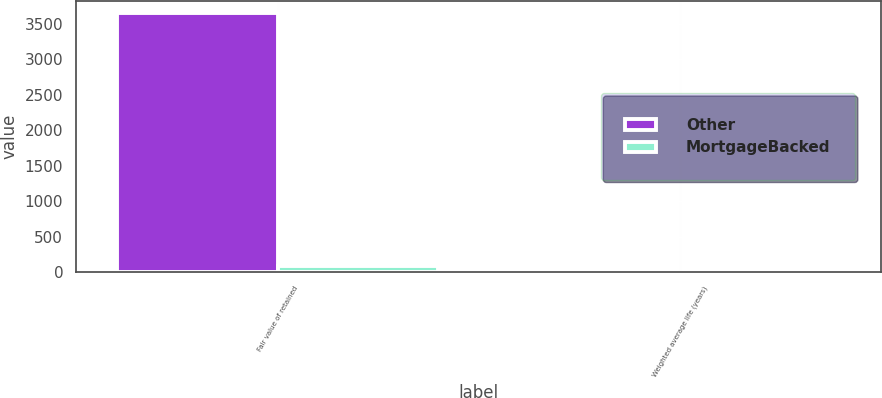<chart> <loc_0><loc_0><loc_500><loc_500><stacked_bar_chart><ecel><fcel>Fair value of retained<fcel>Weighted average life (years)<nl><fcel>Other<fcel>3641<fcel>8.3<nl><fcel>MortgageBacked<fcel>86<fcel>1.9<nl></chart> 